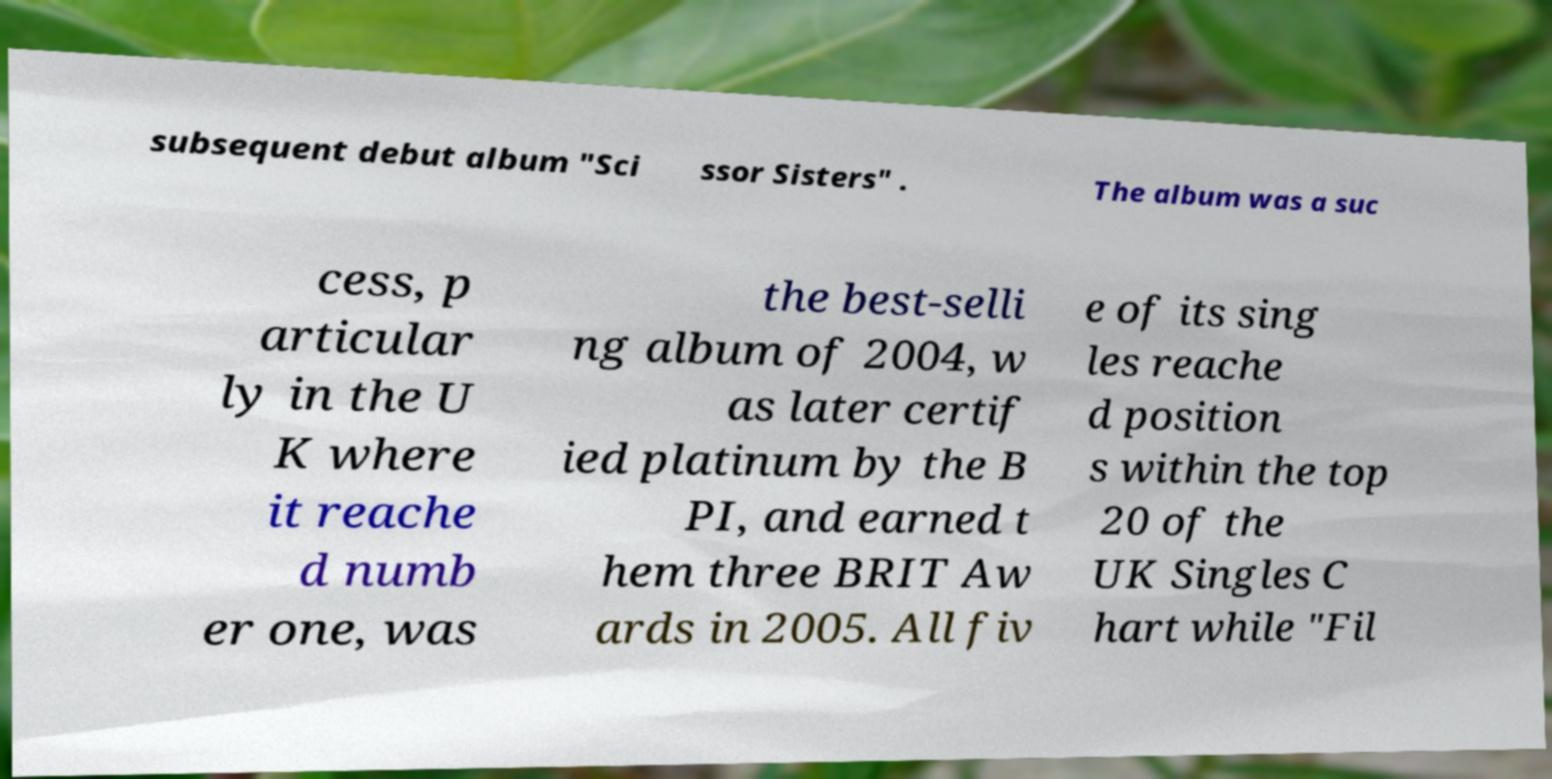Please identify and transcribe the text found in this image. subsequent debut album "Sci ssor Sisters" . The album was a suc cess, p articular ly in the U K where it reache d numb er one, was the best-selli ng album of 2004, w as later certif ied platinum by the B PI, and earned t hem three BRIT Aw ards in 2005. All fiv e of its sing les reache d position s within the top 20 of the UK Singles C hart while "Fil 